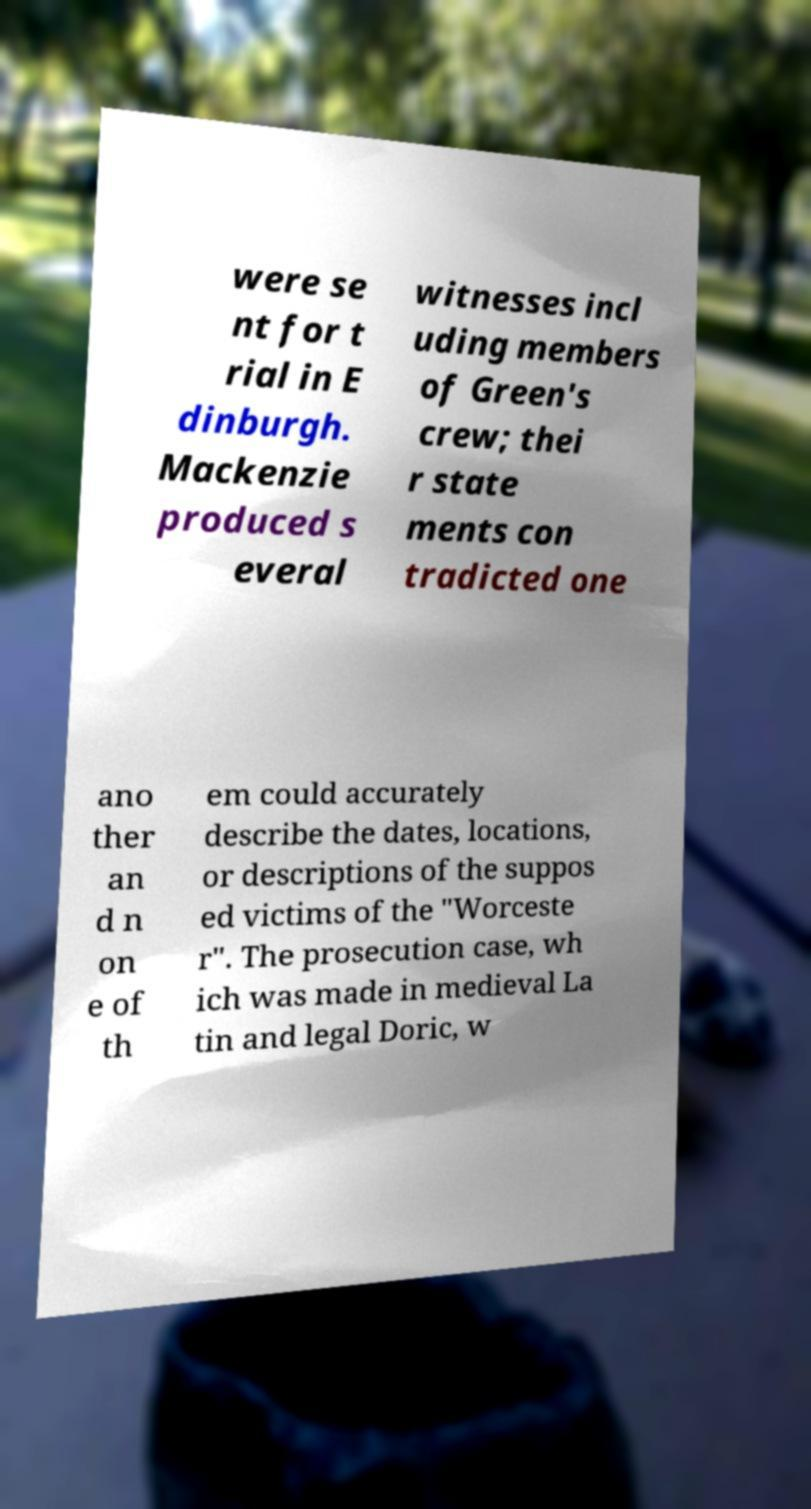I need the written content from this picture converted into text. Can you do that? were se nt for t rial in E dinburgh. Mackenzie produced s everal witnesses incl uding members of Green's crew; thei r state ments con tradicted one ano ther an d n on e of th em could accurately describe the dates, locations, or descriptions of the suppos ed victims of the "Worceste r". The prosecution case, wh ich was made in medieval La tin and legal Doric, w 